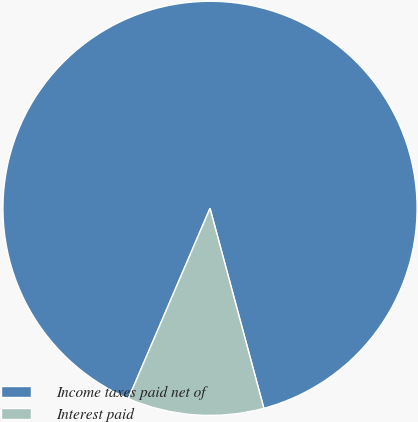Convert chart. <chart><loc_0><loc_0><loc_500><loc_500><pie_chart><fcel>Income taxes paid net of<fcel>Interest paid<nl><fcel>89.36%<fcel>10.64%<nl></chart> 